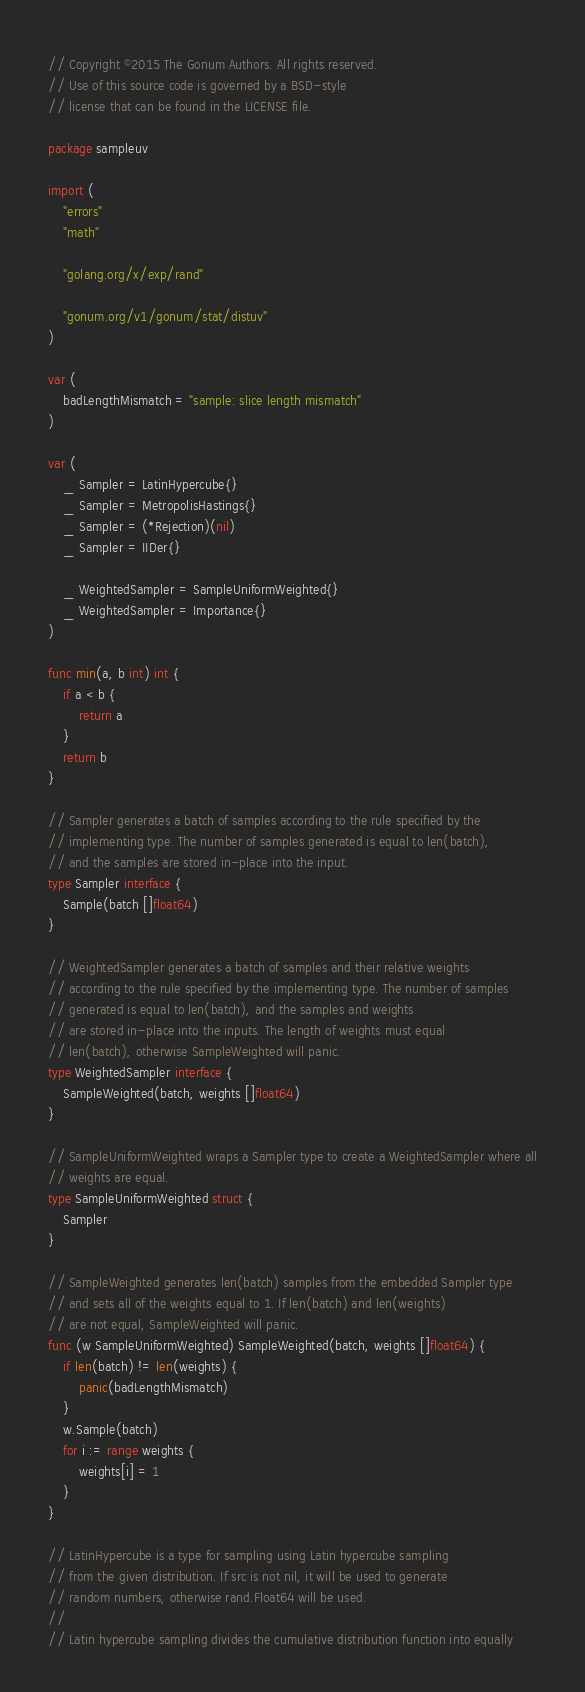<code> <loc_0><loc_0><loc_500><loc_500><_Go_>// Copyright ©2015 The Gonum Authors. All rights reserved.
// Use of this source code is governed by a BSD-style
// license that can be found in the LICENSE file.

package sampleuv

import (
	"errors"
	"math"

	"golang.org/x/exp/rand"

	"gonum.org/v1/gonum/stat/distuv"
)

var (
	badLengthMismatch = "sample: slice length mismatch"
)

var (
	_ Sampler = LatinHypercube{}
	_ Sampler = MetropolisHastings{}
	_ Sampler = (*Rejection)(nil)
	_ Sampler = IIDer{}

	_ WeightedSampler = SampleUniformWeighted{}
	_ WeightedSampler = Importance{}
)

func min(a, b int) int {
	if a < b {
		return a
	}
	return b
}

// Sampler generates a batch of samples according to the rule specified by the
// implementing type. The number of samples generated is equal to len(batch),
// and the samples are stored in-place into the input.
type Sampler interface {
	Sample(batch []float64)
}

// WeightedSampler generates a batch of samples and their relative weights
// according to the rule specified by the implementing type. The number of samples
// generated is equal to len(batch), and the samples and weights
// are stored in-place into the inputs. The length of weights must equal
// len(batch), otherwise SampleWeighted will panic.
type WeightedSampler interface {
	SampleWeighted(batch, weights []float64)
}

// SampleUniformWeighted wraps a Sampler type to create a WeightedSampler where all
// weights are equal.
type SampleUniformWeighted struct {
	Sampler
}

// SampleWeighted generates len(batch) samples from the embedded Sampler type
// and sets all of the weights equal to 1. If len(batch) and len(weights)
// are not equal, SampleWeighted will panic.
func (w SampleUniformWeighted) SampleWeighted(batch, weights []float64) {
	if len(batch) != len(weights) {
		panic(badLengthMismatch)
	}
	w.Sample(batch)
	for i := range weights {
		weights[i] = 1
	}
}

// LatinHypercube is a type for sampling using Latin hypercube sampling
// from the given distribution. If src is not nil, it will be used to generate
// random numbers, otherwise rand.Float64 will be used.
//
// Latin hypercube sampling divides the cumulative distribution function into equally</code> 